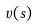<formula> <loc_0><loc_0><loc_500><loc_500>v ( s )</formula> 